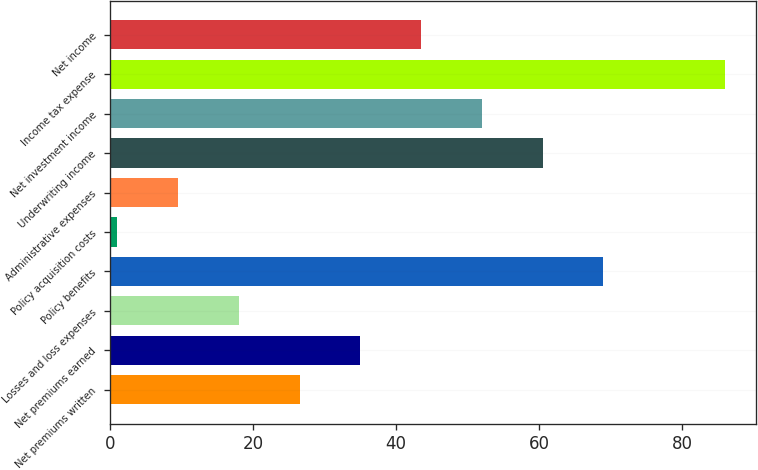<chart> <loc_0><loc_0><loc_500><loc_500><bar_chart><fcel>Net premiums written<fcel>Net premiums earned<fcel>Losses and loss expenses<fcel>Policy benefits<fcel>Policy acquisition costs<fcel>Administrative expenses<fcel>Underwriting income<fcel>Net investment income<fcel>Income tax expense<fcel>Net income<nl><fcel>26.5<fcel>35<fcel>18<fcel>69<fcel>1<fcel>9.5<fcel>60.5<fcel>52<fcel>86<fcel>43.5<nl></chart> 